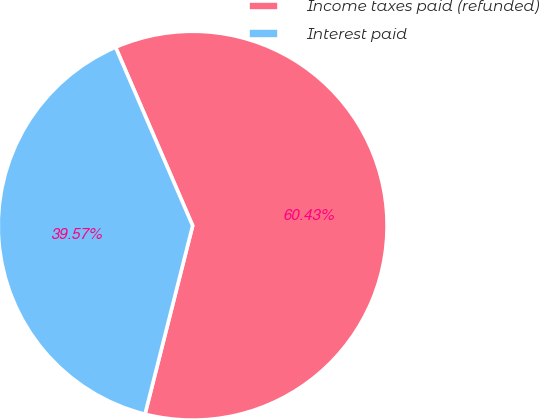Convert chart. <chart><loc_0><loc_0><loc_500><loc_500><pie_chart><fcel>Income taxes paid (refunded)<fcel>Interest paid<nl><fcel>60.43%<fcel>39.57%<nl></chart> 